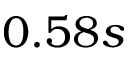Convert formula to latex. <formula><loc_0><loc_0><loc_500><loc_500>0 . 5 8 s</formula> 